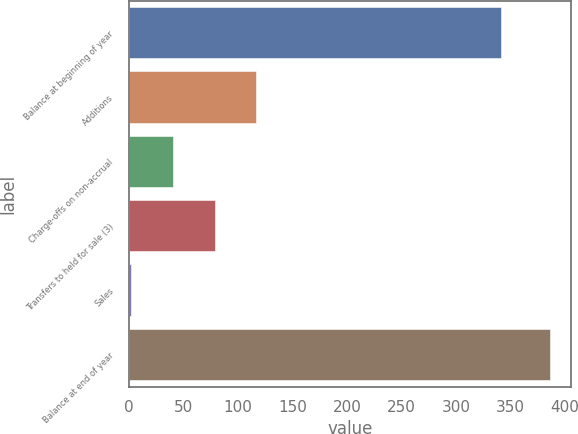Convert chart to OTSL. <chart><loc_0><loc_0><loc_500><loc_500><bar_chart><fcel>Balance at beginning of year<fcel>Additions<fcel>Charge-offs on non-accrual<fcel>Transfers to held for sale (3)<fcel>Sales<fcel>Balance at end of year<nl><fcel>341<fcel>117.2<fcel>40.4<fcel>78.8<fcel>2<fcel>386<nl></chart> 